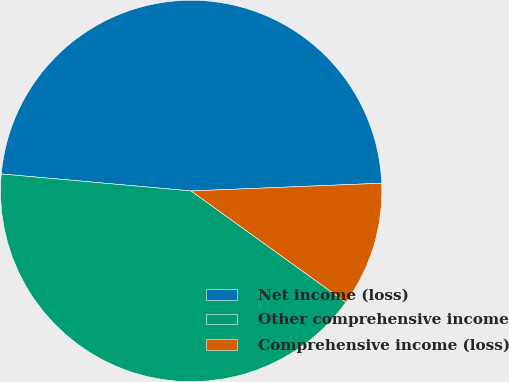Convert chart. <chart><loc_0><loc_0><loc_500><loc_500><pie_chart><fcel>Net income (loss)<fcel>Other comprehensive income<fcel>Comprehensive income (loss)<nl><fcel>47.93%<fcel>41.49%<fcel>10.58%<nl></chart> 